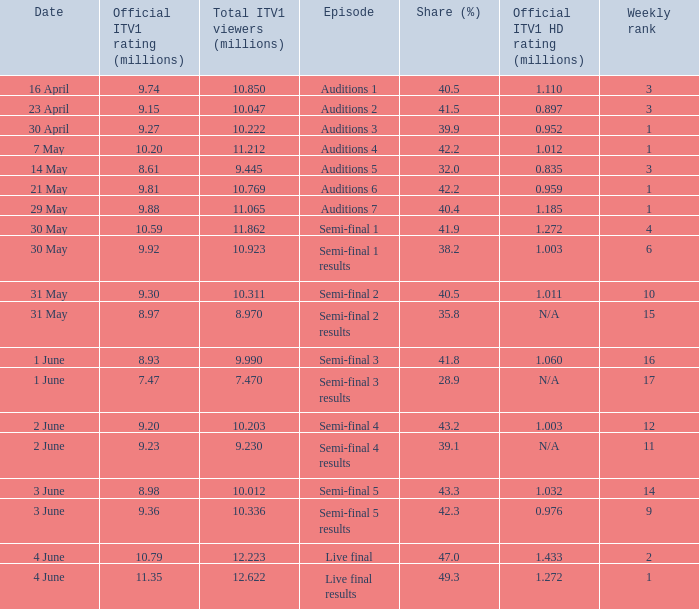What was the official ITV1 HD rating in millions for the episode that had an official ITV1 rating of 8.98 million? 1.032. 